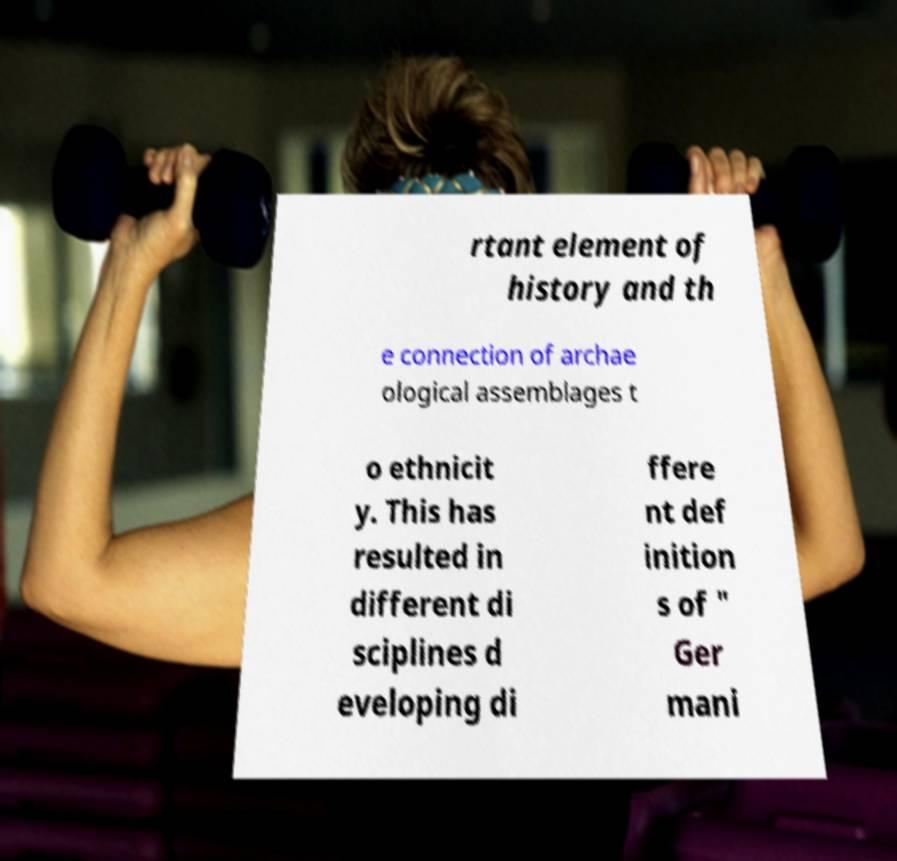For documentation purposes, I need the text within this image transcribed. Could you provide that? rtant element of history and th e connection of archae ological assemblages t o ethnicit y. This has resulted in different di sciplines d eveloping di ffere nt def inition s of " Ger mani 